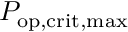Convert formula to latex. <formula><loc_0><loc_0><loc_500><loc_500>P _ { o p , c r i t , \max }</formula> 